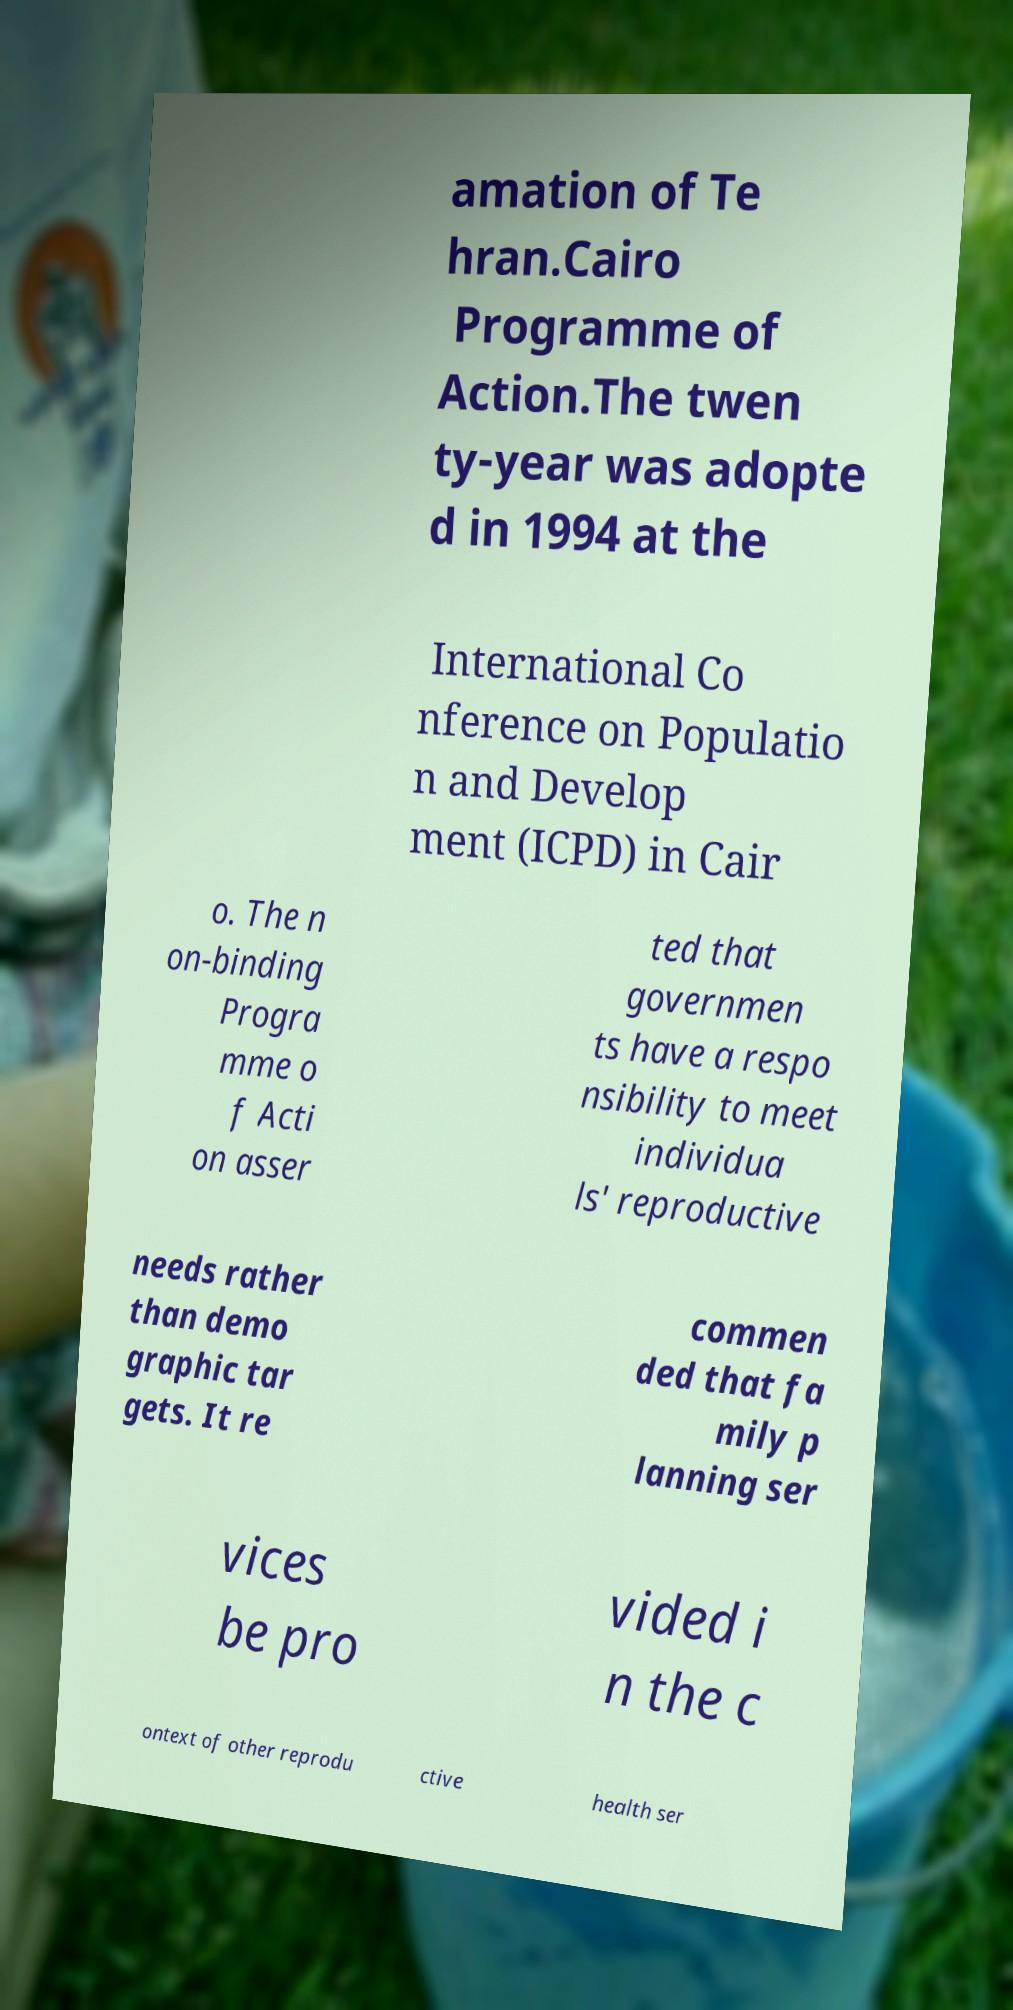What messages or text are displayed in this image? I need them in a readable, typed format. amation of Te hran.Cairo Programme of Action.The twen ty-year was adopte d in 1994 at the International Co nference on Populatio n and Develop ment (ICPD) in Cair o. The n on-binding Progra mme o f Acti on asser ted that governmen ts have a respo nsibility to meet individua ls' reproductive needs rather than demo graphic tar gets. It re commen ded that fa mily p lanning ser vices be pro vided i n the c ontext of other reprodu ctive health ser 